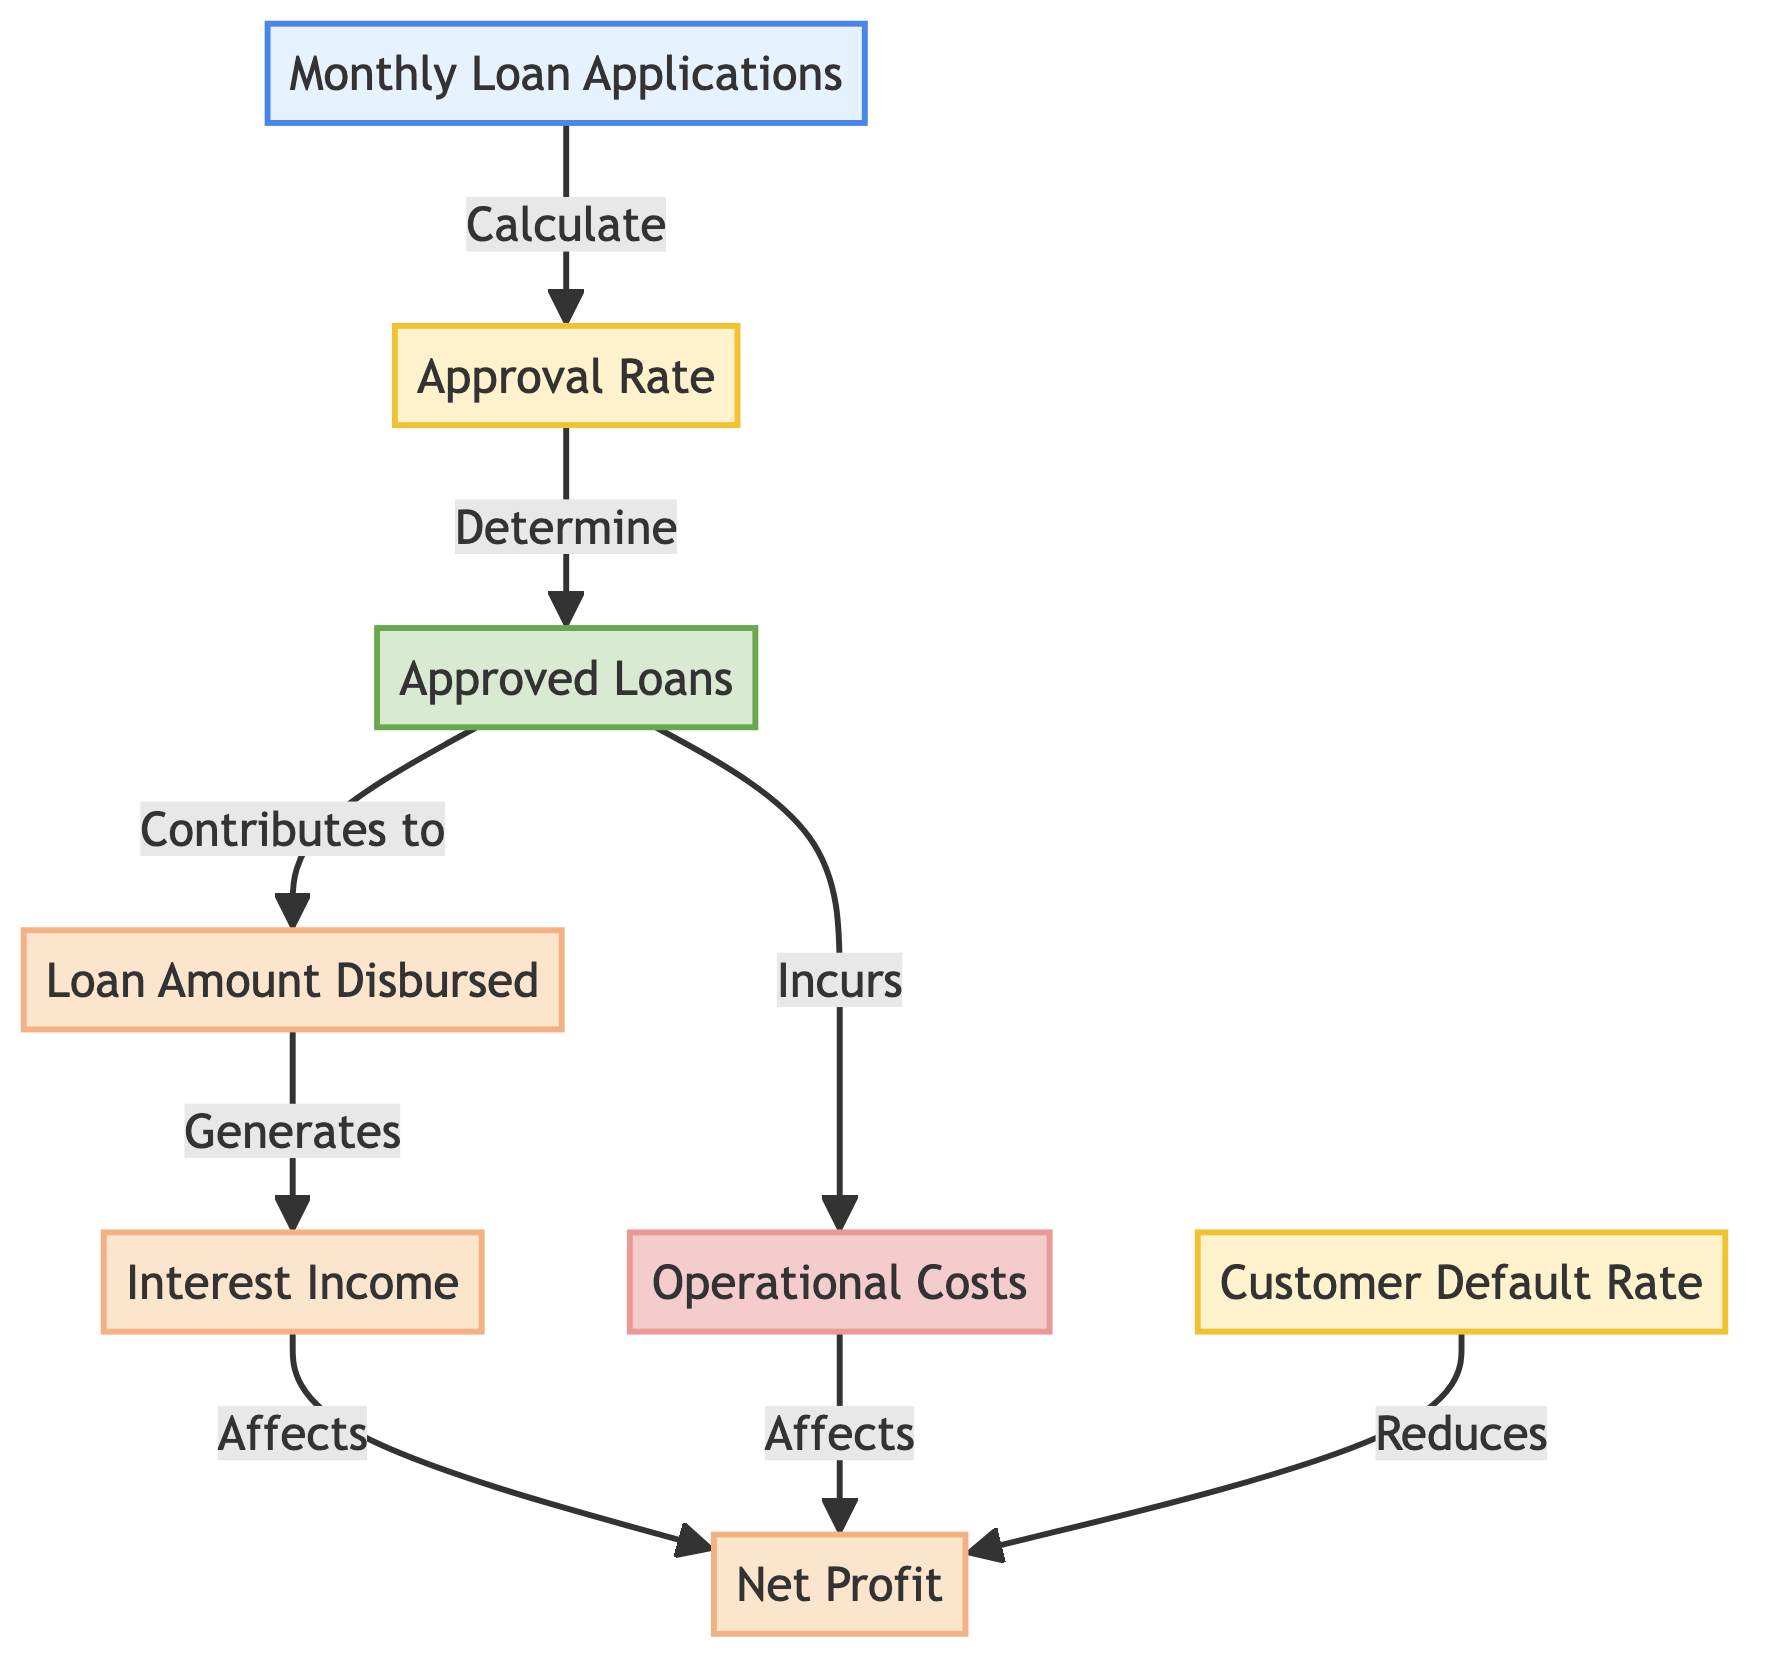What's the node that tracks the percentage of loan approvals? The node labeled "Approval Rate" shows how many of the monthly loan applications are approved, indicating this percentage.
Answer: Approval Rate What happens to the "Loan Amount Disbursed" after "Approved Loans"? The approved loans directly lead to the loan amount being disbursed as they contribute to the funds allocated to borrowers.
Answer: Contributes to Which node shows the income generated from disbursed loans? The "Interest Income" node is where the income derived from the loans that have been disbursed is tracked.
Answer: Interest Income What are the two main costs affecting "Net Profit"? The two main costs are "Operational Costs" and the impact of the "Customer Default Rate," both of which reduce the net profit amount.
Answer: Operational Costs, Customer Default Rate How many nodes represent financial outcomes in the diagram? There are four nodes representing financial outcomes: "Loan Amount Disbursed," "Interest Income," "Net Profit," and "Customer Default Rate."
Answer: Four How does the “Customer Default Rate” affect “Net Profit”? The "Customer Default Rate" reduces the "Net Profit" since defaults mean that the bank loses on the expected income from those loans, impacting overall profitability.
Answer: Reduces What is the relationship between “Approved Loans” and “Operational Costs”? "Approved Loans" incurs "Operational Costs" because the process of approving loans involves administrative and operational expenditures.
Answer: Incurs What does the "Interest Income" node depend on? The "Interest Income" is generated based on the amount of loans that have been approved and disbursed, linking these two elements tightly together.
Answer: Generates Which node is slated to show the total profit after considering all factors? The "Net Profit" node reflects the total profitability after accounting for aspects like interest income and various costs including operational costs and defaults.
Answer: Net Profit 